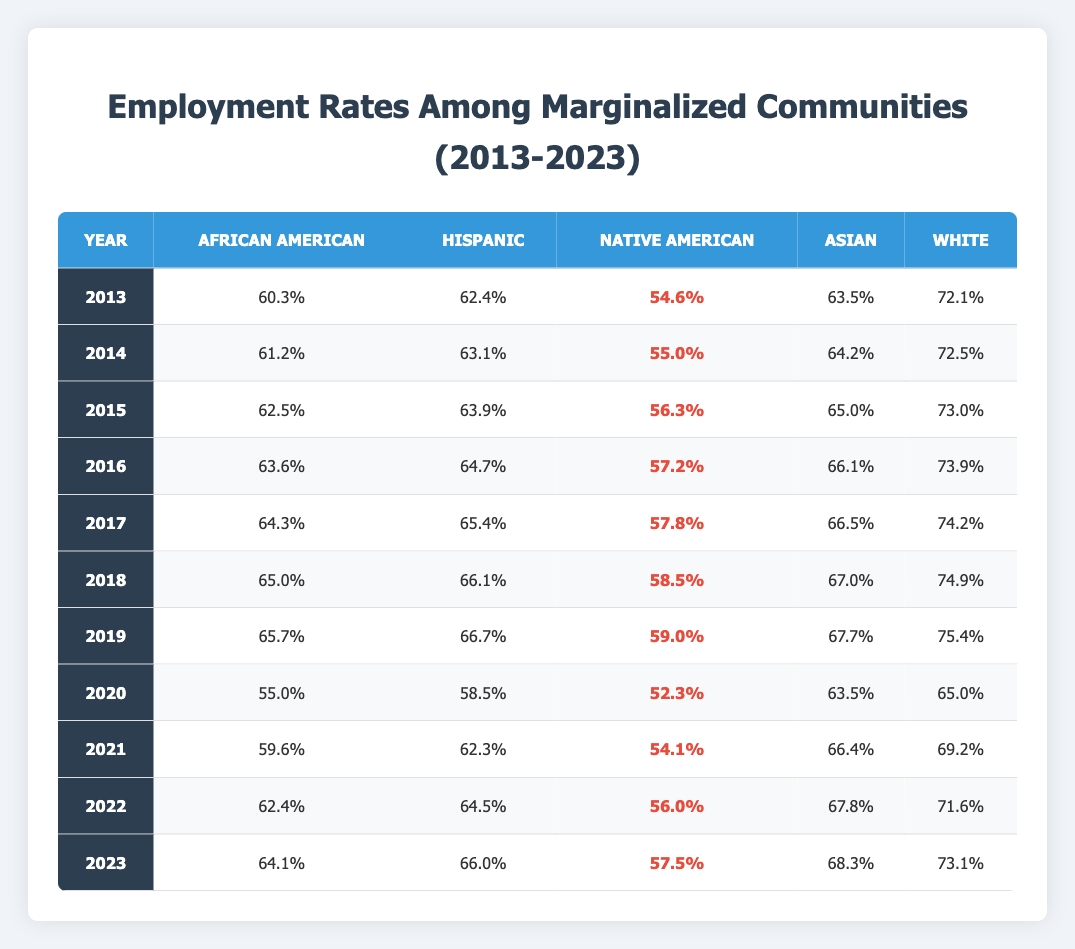What was the employment rate for African Americans in 2020? In the table under the year 2020, the employment rate for African Americans is listed as 55.0%.
Answer: 55.0% Which group had the highest employment rate in 2019? Looking at the table for the year 2019, the highest employment rate is for the White group at 75.4%.
Answer: White How much did the employment rate for Hispanics increase from 2013 to 2023? The Hispanic employment rate in 2013 was 62.4% and in 2023 it is 66.0%. To find the increase, we calculate 66.0% - 62.4% = 3.6%.
Answer: 3.6% What was the average employment rate for Native Americans from 2013 to 2023? The employment rates for Native Americans from 2013 to 2023 are 54.6%, 55.0%, 56.3%, 57.2%, 57.8%, 58.5%, 59.0%, 52.3%, 54.1%, 56.0%, and 57.5%. Summing these, we get 627.3%. Dividing by 11 (the number of years) gives an average of 57.0%.
Answer: 57.0% Which year had the lowest employment rate for Asians? The table shows that the lowest employment rate for Asians was in 2020 at 63.5%.
Answer: 63.5% Did the employment rate for African Americans ever drop below 60% in the past decade? Yes, in 2020 the employment rate for African Americans fell to 55.0%, which is below 60%.
Answer: Yes Which group had the most significant decrease in employment rate in 2020 compared to 2019? The employment rates for 2019 and 2020 are as follows: African American (65.7% to 55.0%), Hispanic (66.7% to 58.5%), Native American (59.0% to 52.3%), Asian (67.7% to 63.5%), and White (75.4% to 65.0%). The Native American group had the biggest decline of 6.7% (59.0% - 52.3%).
Answer: Native American What was the trend in employment rates for African Americans from 2013 to 2023? Reviewing the table, the rates for African Americans increased steadily from 60.3% in 2013 to 64.1% in 2023, with a significant drop in 2020.
Answer: Increased overall, with a drop in 2020 How do the 2023 employment rates for marginalized groups compare to the 2013 rates? In 2023, African Americans are at 64.1%, which is an increase from 60.3%; Hispanics are at 66.0%, up from 62.4%; Native Americans at 57.5%, up from 54.6%; Asians at 68.3%, up from 63.5%; Whites at 73.1%, up from 72.1%. All groups increased over the decade.
Answer: All groups increased What percentage of employment does the Asian group have compared to the White group in 2023? In 2023, the Asian employment rate is 68.3% and the White rate is 73.1%. The difference is 73.1% - 68.3% = 4.8%. This shows Asians are 4.8% less employed than Whites.
Answer: 4.8% less assigned 